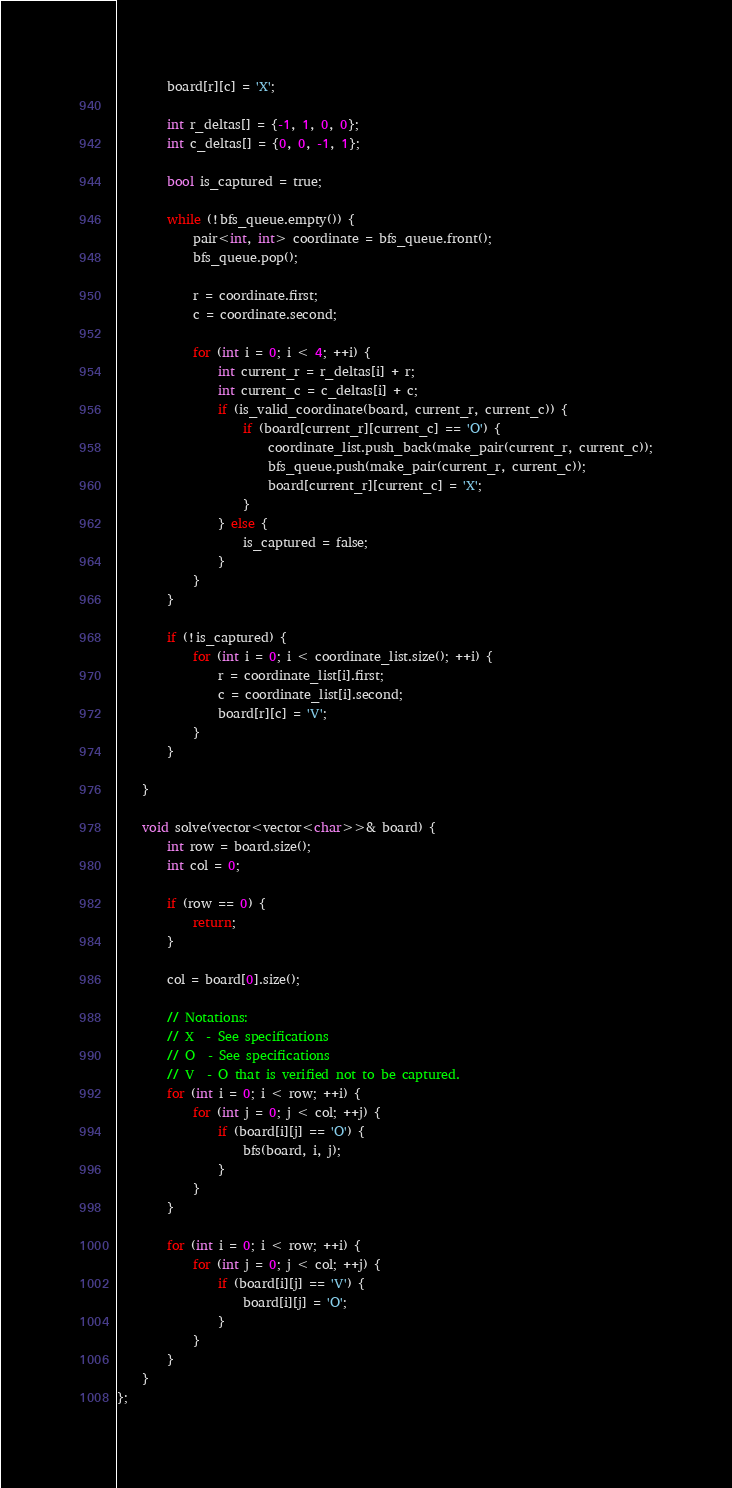<code> <loc_0><loc_0><loc_500><loc_500><_C++_>        board[r][c] = 'X';

        int r_deltas[] = {-1, 1, 0, 0};
        int c_deltas[] = {0, 0, -1, 1};

        bool is_captured = true;

        while (!bfs_queue.empty()) {
            pair<int, int> coordinate = bfs_queue.front();
            bfs_queue.pop();

            r = coordinate.first;
            c = coordinate.second;
            
            for (int i = 0; i < 4; ++i) {
                int current_r = r_deltas[i] + r;
                int current_c = c_deltas[i] + c;
                if (is_valid_coordinate(board, current_r, current_c)) {
                    if (board[current_r][current_c] == 'O') {
                        coordinate_list.push_back(make_pair(current_r, current_c));
                        bfs_queue.push(make_pair(current_r, current_c));
                        board[current_r][current_c] = 'X';
                    } 
                } else {
                    is_captured = false;
                }
            } 
        }

        if (!is_captured) {
            for (int i = 0; i < coordinate_list.size(); ++i) {
                r = coordinate_list[i].first; 
                c = coordinate_list[i].second;
                board[r][c] = 'V';
            }
        }

    }

    void solve(vector<vector<char>>& board) {
        int row = board.size();
        int col = 0;

        if (row == 0) {
            return;
        }

        col = board[0].size();

        // Notations:
        // X  - See specifications
        // O  - See specifications
        // V  - O that is verified not to be captured. 
        for (int i = 0; i < row; ++i) {
            for (int j = 0; j < col; ++j) {
                if (board[i][j] == 'O') {
                    bfs(board, i, j);
                } 
            }
        }

        for (int i = 0; i < row; ++i) {
            for (int j = 0; j < col; ++j) {
                if (board[i][j] == 'V') {
                    board[i][j] = 'O';
                }
            }
        }
    }
};</code> 